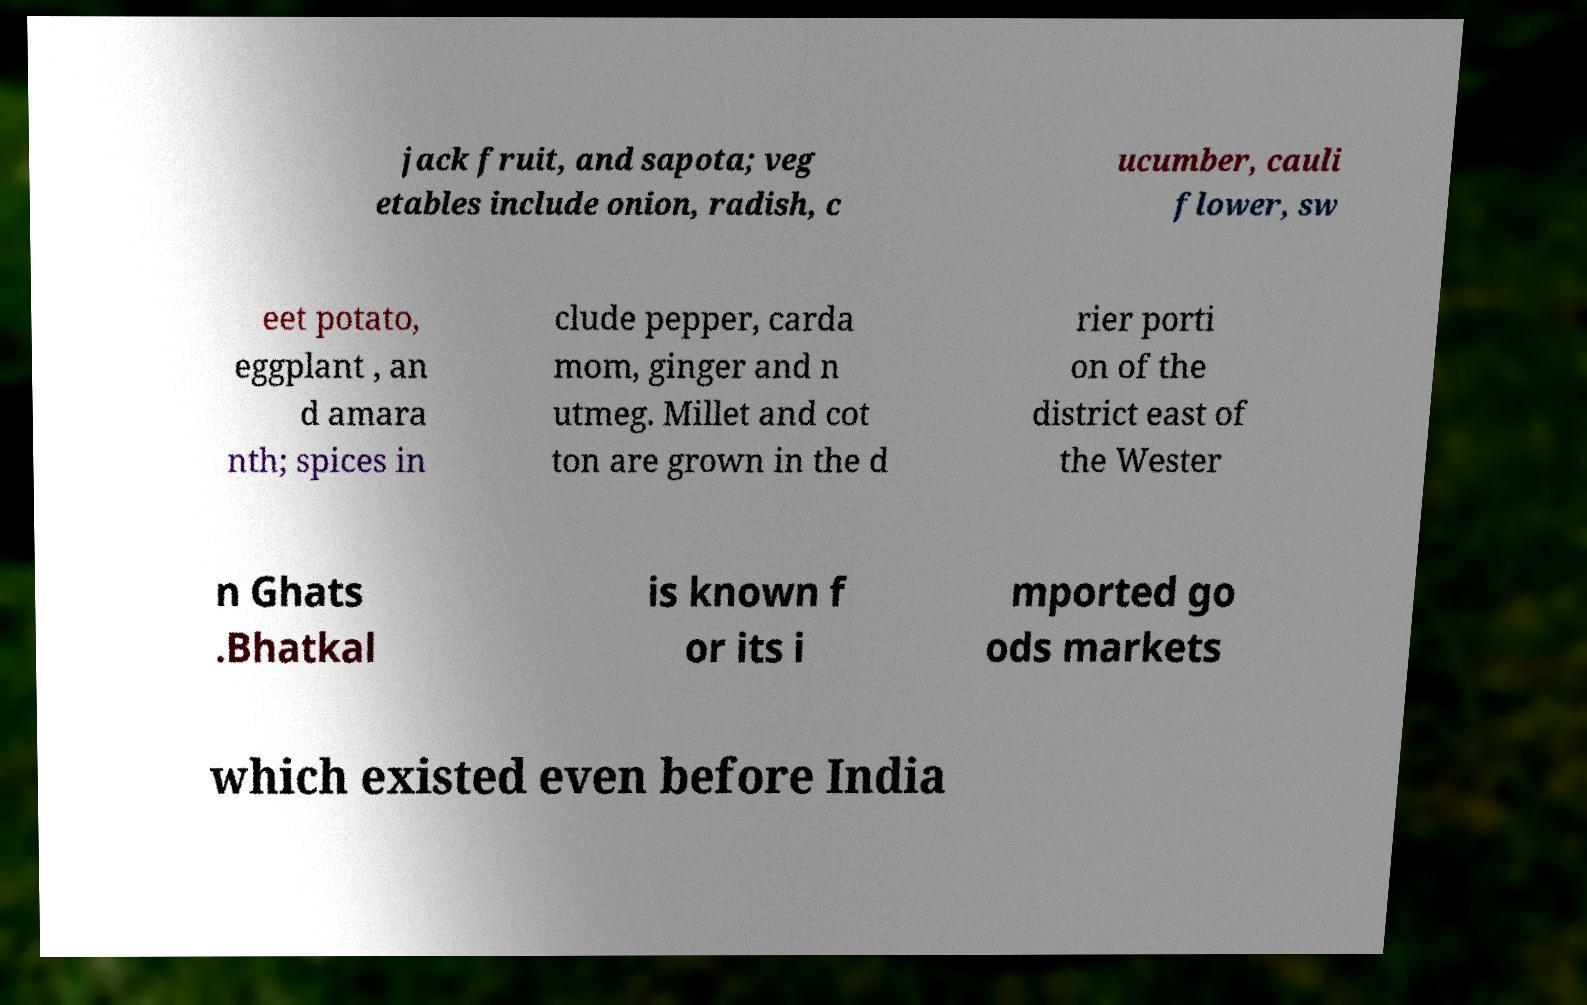Can you read and provide the text displayed in the image?This photo seems to have some interesting text. Can you extract and type it out for me? jack fruit, and sapota; veg etables include onion, radish, c ucumber, cauli flower, sw eet potato, eggplant , an d amara nth; spices in clude pepper, carda mom, ginger and n utmeg. Millet and cot ton are grown in the d rier porti on of the district east of the Wester n Ghats .Bhatkal is known f or its i mported go ods markets which existed even before India 